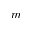Convert formula to latex. <formula><loc_0><loc_0><loc_500><loc_500>m</formula> 